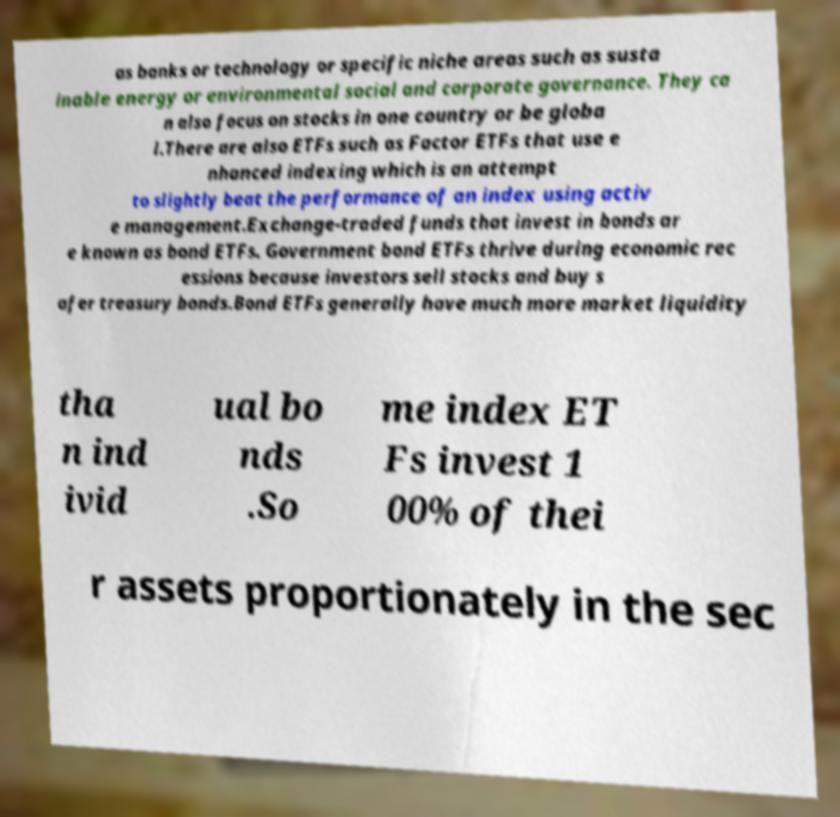There's text embedded in this image that I need extracted. Can you transcribe it verbatim? as banks or technology or specific niche areas such as susta inable energy or environmental social and corporate governance. They ca n also focus on stocks in one country or be globa l.There are also ETFs such as Factor ETFs that use e nhanced indexing which is an attempt to slightly beat the performance of an index using activ e management.Exchange-traded funds that invest in bonds ar e known as bond ETFs. Government bond ETFs thrive during economic rec essions because investors sell stocks and buy s afer treasury bonds.Bond ETFs generally have much more market liquidity tha n ind ivid ual bo nds .So me index ET Fs invest 1 00% of thei r assets proportionately in the sec 